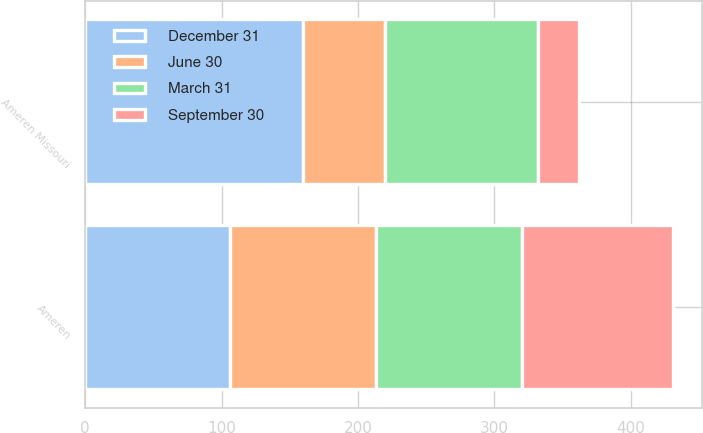Convert chart. <chart><loc_0><loc_0><loc_500><loc_500><stacked_bar_chart><ecel><fcel>Ameren Missouri<fcel>Ameren<nl><fcel>September 30<fcel>30<fcel>111<nl><fcel>December 31<fcel>160<fcel>106<nl><fcel>March 31<fcel>112<fcel>107<nl><fcel>June 30<fcel>60<fcel>107<nl></chart> 